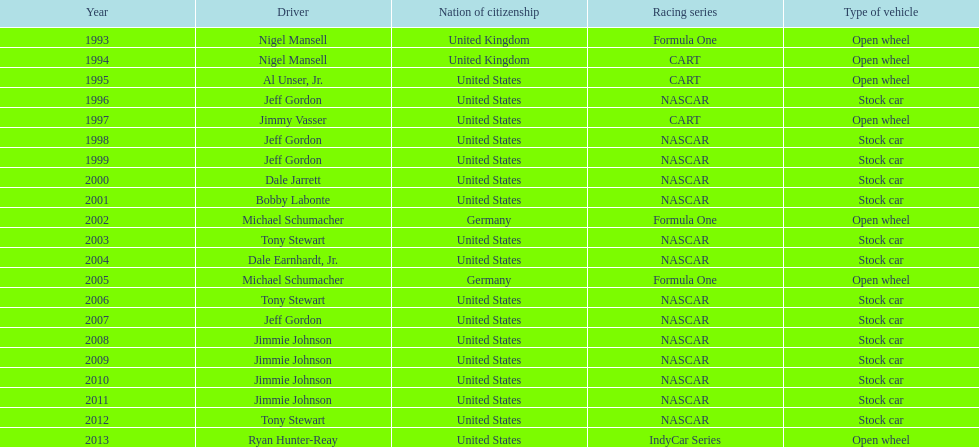Who is the driver with a streak of four successive wins? Jimmie Johnson. 